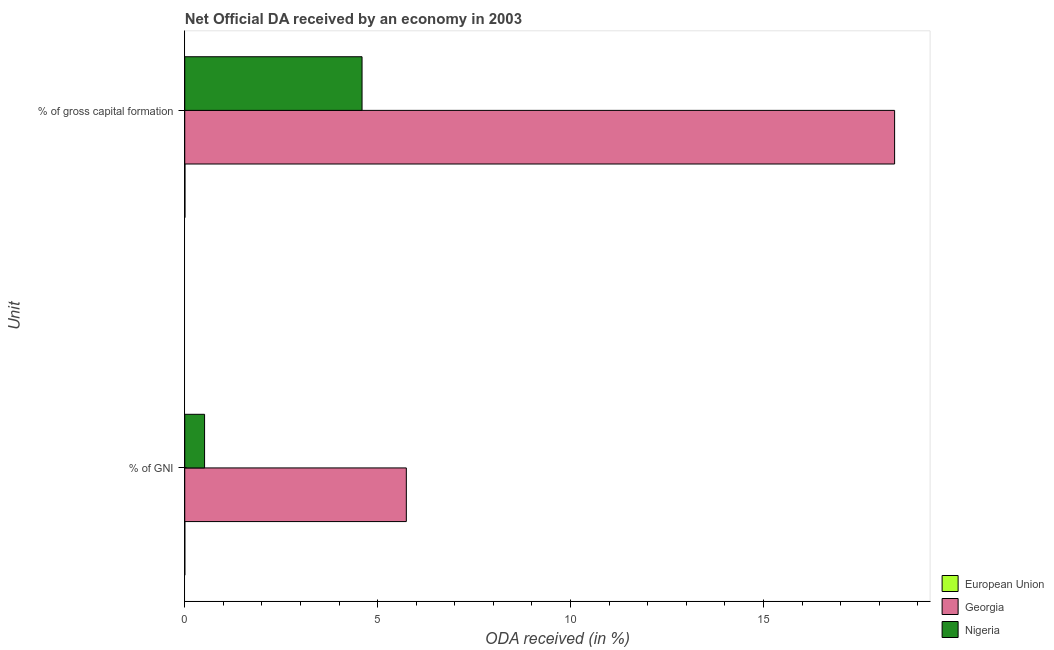How many different coloured bars are there?
Make the answer very short. 3. Are the number of bars on each tick of the Y-axis equal?
Keep it short and to the point. Yes. How many bars are there on the 1st tick from the top?
Ensure brevity in your answer.  3. How many bars are there on the 1st tick from the bottom?
Your response must be concise. 3. What is the label of the 1st group of bars from the top?
Offer a very short reply. % of gross capital formation. What is the oda received as percentage of gni in Nigeria?
Your answer should be compact. 0.51. Across all countries, what is the maximum oda received as percentage of gross capital formation?
Ensure brevity in your answer.  18.4. Across all countries, what is the minimum oda received as percentage of gni?
Your answer should be very brief. 0. In which country was the oda received as percentage of gni maximum?
Your answer should be compact. Georgia. In which country was the oda received as percentage of gni minimum?
Your response must be concise. European Union. What is the total oda received as percentage of gross capital formation in the graph?
Keep it short and to the point. 23. What is the difference between the oda received as percentage of gni in European Union and that in Nigeria?
Your response must be concise. -0.51. What is the difference between the oda received as percentage of gni in European Union and the oda received as percentage of gross capital formation in Georgia?
Keep it short and to the point. -18.4. What is the average oda received as percentage of gross capital formation per country?
Provide a short and direct response. 7.67. What is the difference between the oda received as percentage of gni and oda received as percentage of gross capital formation in European Union?
Offer a terse response. -0. In how many countries, is the oda received as percentage of gni greater than 12 %?
Make the answer very short. 0. What is the ratio of the oda received as percentage of gni in Nigeria to that in European Union?
Your answer should be compact. 504.4. What does the 2nd bar from the top in % of gross capital formation represents?
Provide a succinct answer. Georgia. What does the 2nd bar from the bottom in % of GNI represents?
Ensure brevity in your answer.  Georgia. How many bars are there?
Keep it short and to the point. 6. Are all the bars in the graph horizontal?
Your answer should be very brief. Yes. Are the values on the major ticks of X-axis written in scientific E-notation?
Offer a very short reply. No. Does the graph contain any zero values?
Keep it short and to the point. No. Does the graph contain grids?
Provide a short and direct response. No. How are the legend labels stacked?
Give a very brief answer. Vertical. What is the title of the graph?
Give a very brief answer. Net Official DA received by an economy in 2003. Does "Virgin Islands" appear as one of the legend labels in the graph?
Make the answer very short. No. What is the label or title of the X-axis?
Provide a short and direct response. ODA received (in %). What is the label or title of the Y-axis?
Your answer should be compact. Unit. What is the ODA received (in %) of European Union in % of GNI?
Keep it short and to the point. 0. What is the ODA received (in %) in Georgia in % of GNI?
Make the answer very short. 5.74. What is the ODA received (in %) of Nigeria in % of GNI?
Give a very brief answer. 0.51. What is the ODA received (in %) of European Union in % of gross capital formation?
Ensure brevity in your answer.  0. What is the ODA received (in %) of Georgia in % of gross capital formation?
Ensure brevity in your answer.  18.4. What is the ODA received (in %) in Nigeria in % of gross capital formation?
Your answer should be compact. 4.6. Across all Unit, what is the maximum ODA received (in %) of European Union?
Offer a very short reply. 0. Across all Unit, what is the maximum ODA received (in %) of Georgia?
Your answer should be compact. 18.4. Across all Unit, what is the maximum ODA received (in %) of Nigeria?
Give a very brief answer. 4.6. Across all Unit, what is the minimum ODA received (in %) of European Union?
Your answer should be very brief. 0. Across all Unit, what is the minimum ODA received (in %) of Georgia?
Provide a succinct answer. 5.74. Across all Unit, what is the minimum ODA received (in %) in Nigeria?
Your response must be concise. 0.51. What is the total ODA received (in %) of European Union in the graph?
Make the answer very short. 0.01. What is the total ODA received (in %) of Georgia in the graph?
Ensure brevity in your answer.  24.14. What is the total ODA received (in %) of Nigeria in the graph?
Your response must be concise. 5.11. What is the difference between the ODA received (in %) in European Union in % of GNI and that in % of gross capital formation?
Keep it short and to the point. -0. What is the difference between the ODA received (in %) of Georgia in % of GNI and that in % of gross capital formation?
Keep it short and to the point. -12.66. What is the difference between the ODA received (in %) in Nigeria in % of GNI and that in % of gross capital formation?
Provide a short and direct response. -4.08. What is the difference between the ODA received (in %) in European Union in % of GNI and the ODA received (in %) in Georgia in % of gross capital formation?
Provide a succinct answer. -18.4. What is the difference between the ODA received (in %) in European Union in % of GNI and the ODA received (in %) in Nigeria in % of gross capital formation?
Offer a very short reply. -4.59. What is the difference between the ODA received (in %) of Georgia in % of GNI and the ODA received (in %) of Nigeria in % of gross capital formation?
Your answer should be compact. 1.15. What is the average ODA received (in %) of European Union per Unit?
Provide a short and direct response. 0. What is the average ODA received (in %) in Georgia per Unit?
Give a very brief answer. 12.07. What is the average ODA received (in %) of Nigeria per Unit?
Give a very brief answer. 2.55. What is the difference between the ODA received (in %) of European Union and ODA received (in %) of Georgia in % of GNI?
Make the answer very short. -5.74. What is the difference between the ODA received (in %) of European Union and ODA received (in %) of Nigeria in % of GNI?
Ensure brevity in your answer.  -0.51. What is the difference between the ODA received (in %) of Georgia and ODA received (in %) of Nigeria in % of GNI?
Provide a succinct answer. 5.23. What is the difference between the ODA received (in %) in European Union and ODA received (in %) in Georgia in % of gross capital formation?
Ensure brevity in your answer.  -18.39. What is the difference between the ODA received (in %) of European Union and ODA received (in %) of Nigeria in % of gross capital formation?
Keep it short and to the point. -4.59. What is the difference between the ODA received (in %) of Georgia and ODA received (in %) of Nigeria in % of gross capital formation?
Ensure brevity in your answer.  13.8. What is the ratio of the ODA received (in %) in European Union in % of GNI to that in % of gross capital formation?
Offer a very short reply. 0.21. What is the ratio of the ODA received (in %) in Georgia in % of GNI to that in % of gross capital formation?
Provide a short and direct response. 0.31. What is the ratio of the ODA received (in %) in Nigeria in % of GNI to that in % of gross capital formation?
Provide a succinct answer. 0.11. What is the difference between the highest and the second highest ODA received (in %) in European Union?
Your answer should be very brief. 0. What is the difference between the highest and the second highest ODA received (in %) in Georgia?
Your response must be concise. 12.66. What is the difference between the highest and the second highest ODA received (in %) in Nigeria?
Your answer should be very brief. 4.08. What is the difference between the highest and the lowest ODA received (in %) in European Union?
Your response must be concise. 0. What is the difference between the highest and the lowest ODA received (in %) in Georgia?
Your response must be concise. 12.66. What is the difference between the highest and the lowest ODA received (in %) in Nigeria?
Give a very brief answer. 4.08. 